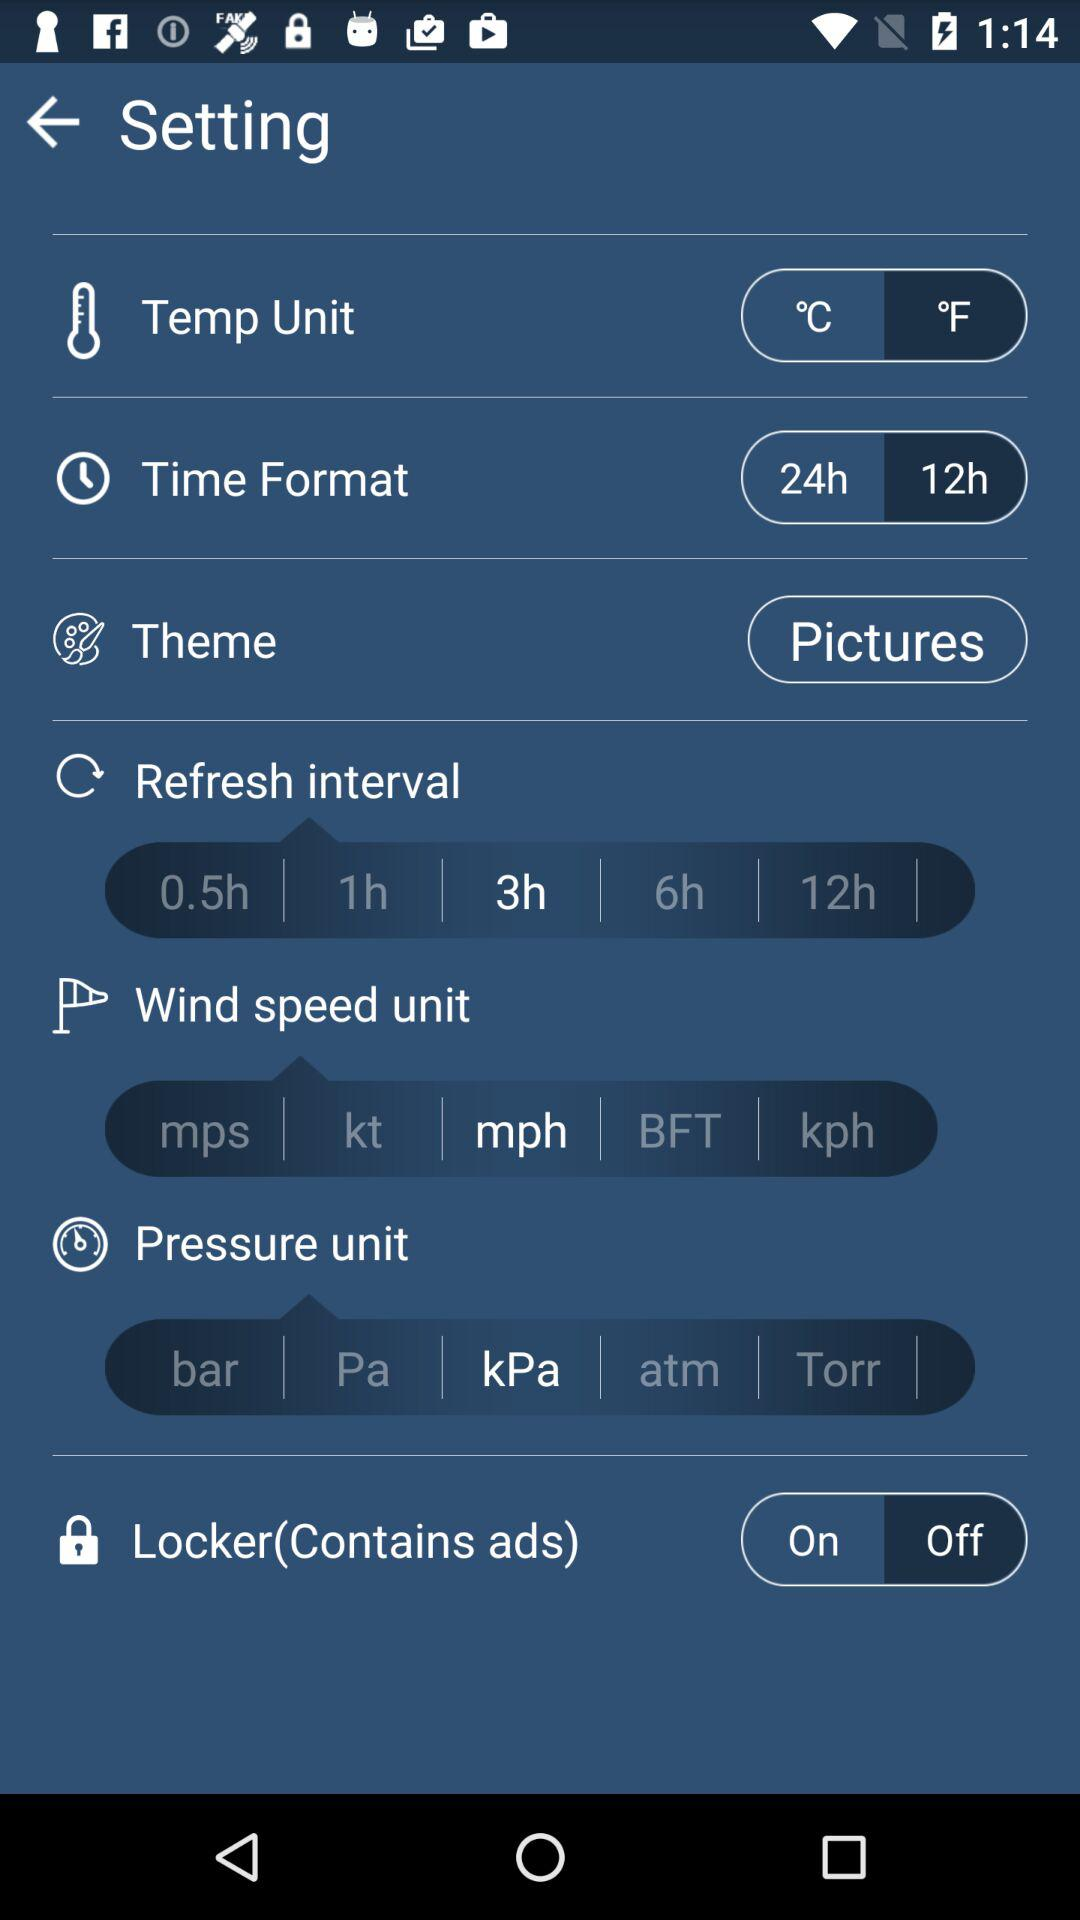What is the unit of temperature? The unit of temperature is °C. 